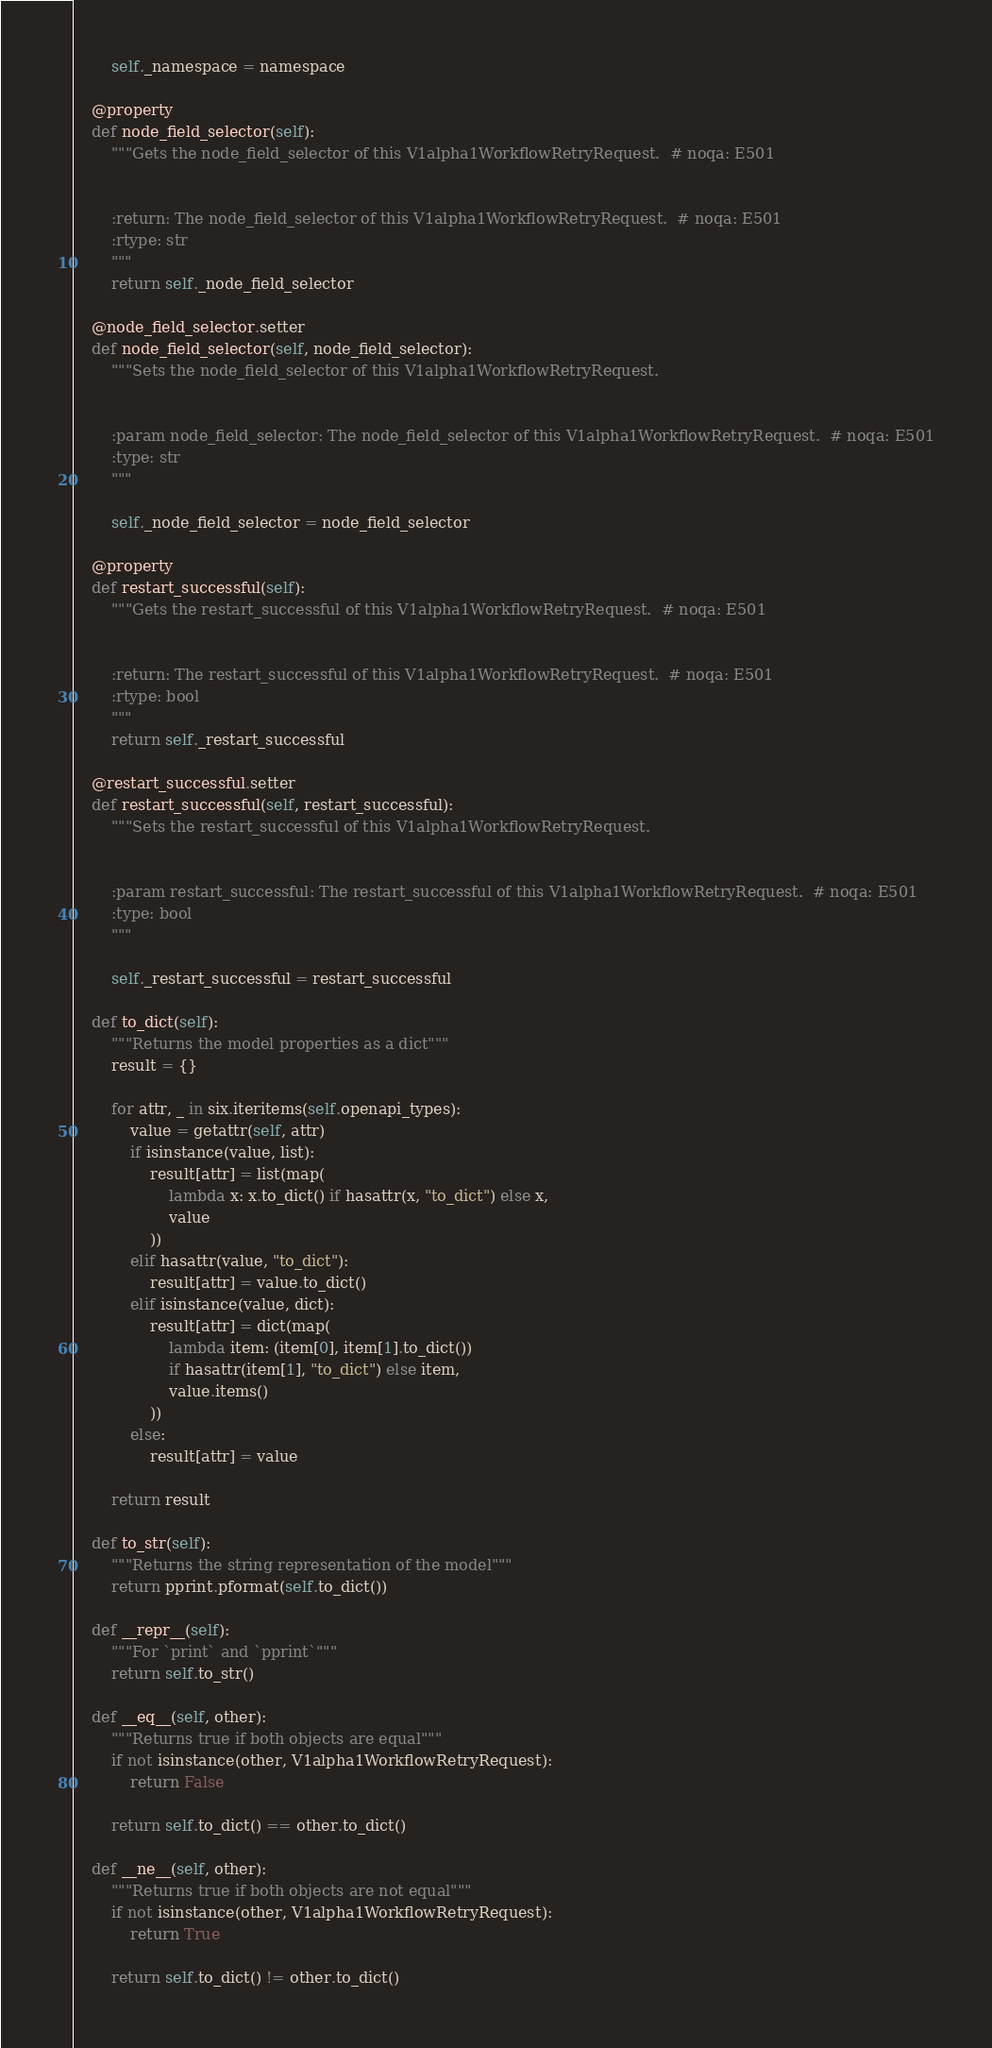Convert code to text. <code><loc_0><loc_0><loc_500><loc_500><_Python_>        self._namespace = namespace

    @property
    def node_field_selector(self):
        """Gets the node_field_selector of this V1alpha1WorkflowRetryRequest.  # noqa: E501


        :return: The node_field_selector of this V1alpha1WorkflowRetryRequest.  # noqa: E501
        :rtype: str
        """
        return self._node_field_selector

    @node_field_selector.setter
    def node_field_selector(self, node_field_selector):
        """Sets the node_field_selector of this V1alpha1WorkflowRetryRequest.


        :param node_field_selector: The node_field_selector of this V1alpha1WorkflowRetryRequest.  # noqa: E501
        :type: str
        """

        self._node_field_selector = node_field_selector

    @property
    def restart_successful(self):
        """Gets the restart_successful of this V1alpha1WorkflowRetryRequest.  # noqa: E501


        :return: The restart_successful of this V1alpha1WorkflowRetryRequest.  # noqa: E501
        :rtype: bool
        """
        return self._restart_successful

    @restart_successful.setter
    def restart_successful(self, restart_successful):
        """Sets the restart_successful of this V1alpha1WorkflowRetryRequest.


        :param restart_successful: The restart_successful of this V1alpha1WorkflowRetryRequest.  # noqa: E501
        :type: bool
        """

        self._restart_successful = restart_successful

    def to_dict(self):
        """Returns the model properties as a dict"""
        result = {}

        for attr, _ in six.iteritems(self.openapi_types):
            value = getattr(self, attr)
            if isinstance(value, list):
                result[attr] = list(map(
                    lambda x: x.to_dict() if hasattr(x, "to_dict") else x,
                    value
                ))
            elif hasattr(value, "to_dict"):
                result[attr] = value.to_dict()
            elif isinstance(value, dict):
                result[attr] = dict(map(
                    lambda item: (item[0], item[1].to_dict())
                    if hasattr(item[1], "to_dict") else item,
                    value.items()
                ))
            else:
                result[attr] = value

        return result

    def to_str(self):
        """Returns the string representation of the model"""
        return pprint.pformat(self.to_dict())

    def __repr__(self):
        """For `print` and `pprint`"""
        return self.to_str()

    def __eq__(self, other):
        """Returns true if both objects are equal"""
        if not isinstance(other, V1alpha1WorkflowRetryRequest):
            return False

        return self.to_dict() == other.to_dict()

    def __ne__(self, other):
        """Returns true if both objects are not equal"""
        if not isinstance(other, V1alpha1WorkflowRetryRequest):
            return True

        return self.to_dict() != other.to_dict()
</code> 